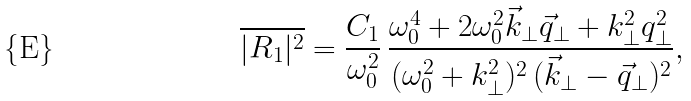Convert formula to latex. <formula><loc_0><loc_0><loc_500><loc_500>\overline { | R _ { 1 } | ^ { 2 } } = \frac { C _ { 1 } } { \omega _ { 0 } ^ { 2 } } \, \frac { \omega _ { 0 } ^ { 4 } + 2 \omega _ { 0 } ^ { 2 } \vec { k } _ { \perp } \vec { q } _ { \perp } + k _ { \perp } ^ { 2 } q _ { \perp } ^ { 2 } } { ( \omega _ { 0 } ^ { 2 } + k _ { \perp } ^ { 2 } ) ^ { 2 } \, ( \vec { k } _ { \perp } - \vec { q } _ { \perp } ) ^ { 2 } } ,</formula> 